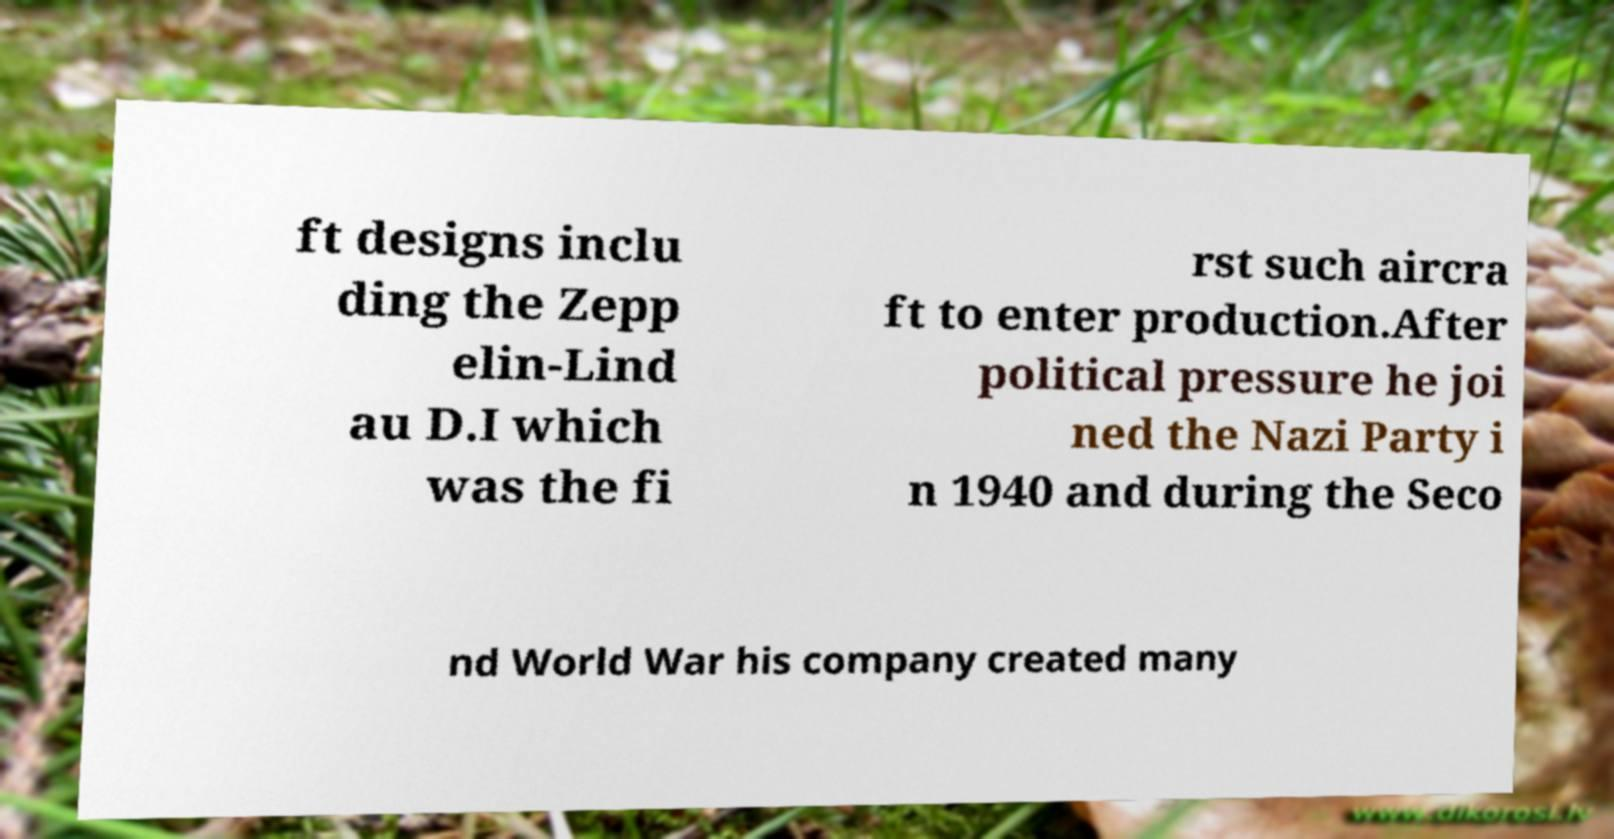Can you read and provide the text displayed in the image?This photo seems to have some interesting text. Can you extract and type it out for me? ft designs inclu ding the Zepp elin-Lind au D.I which was the fi rst such aircra ft to enter production.After political pressure he joi ned the Nazi Party i n 1940 and during the Seco nd World War his company created many 